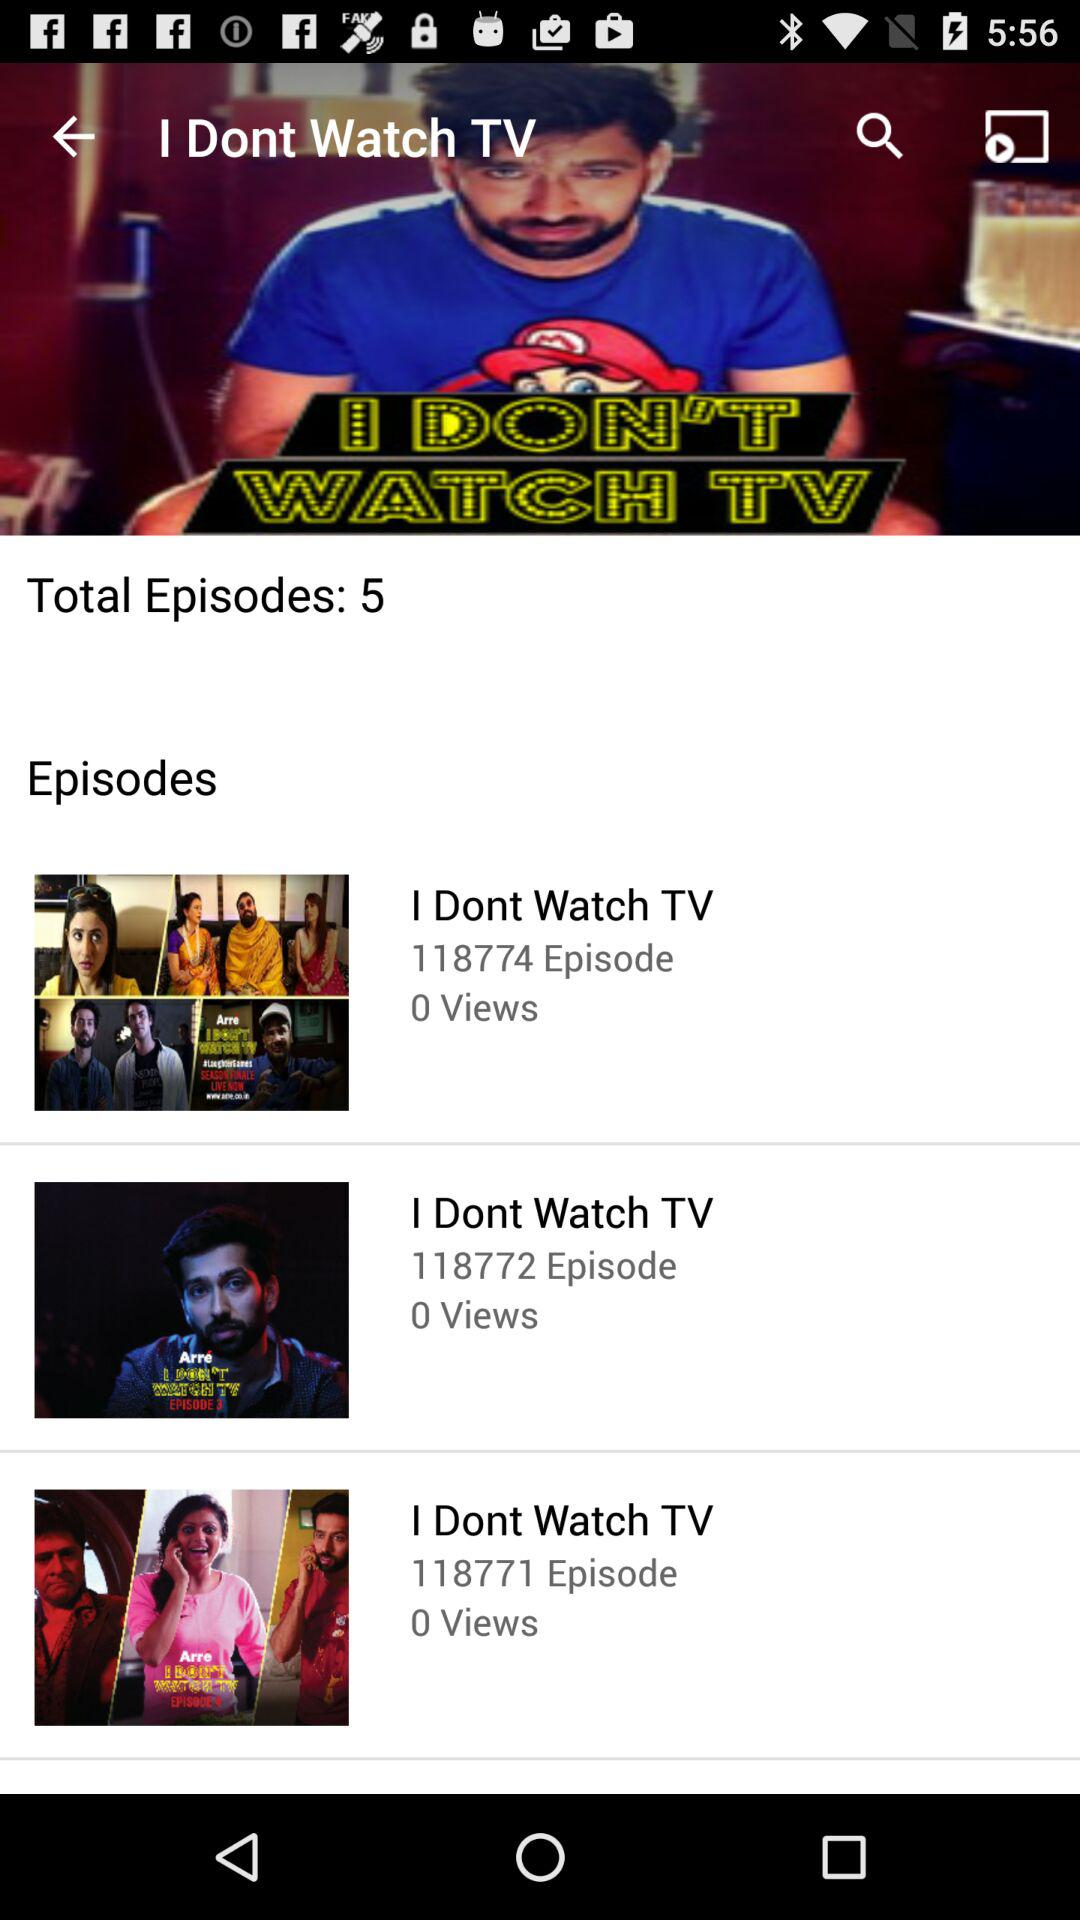What is the episode name? The episode name is "I Dont Watch TV". 